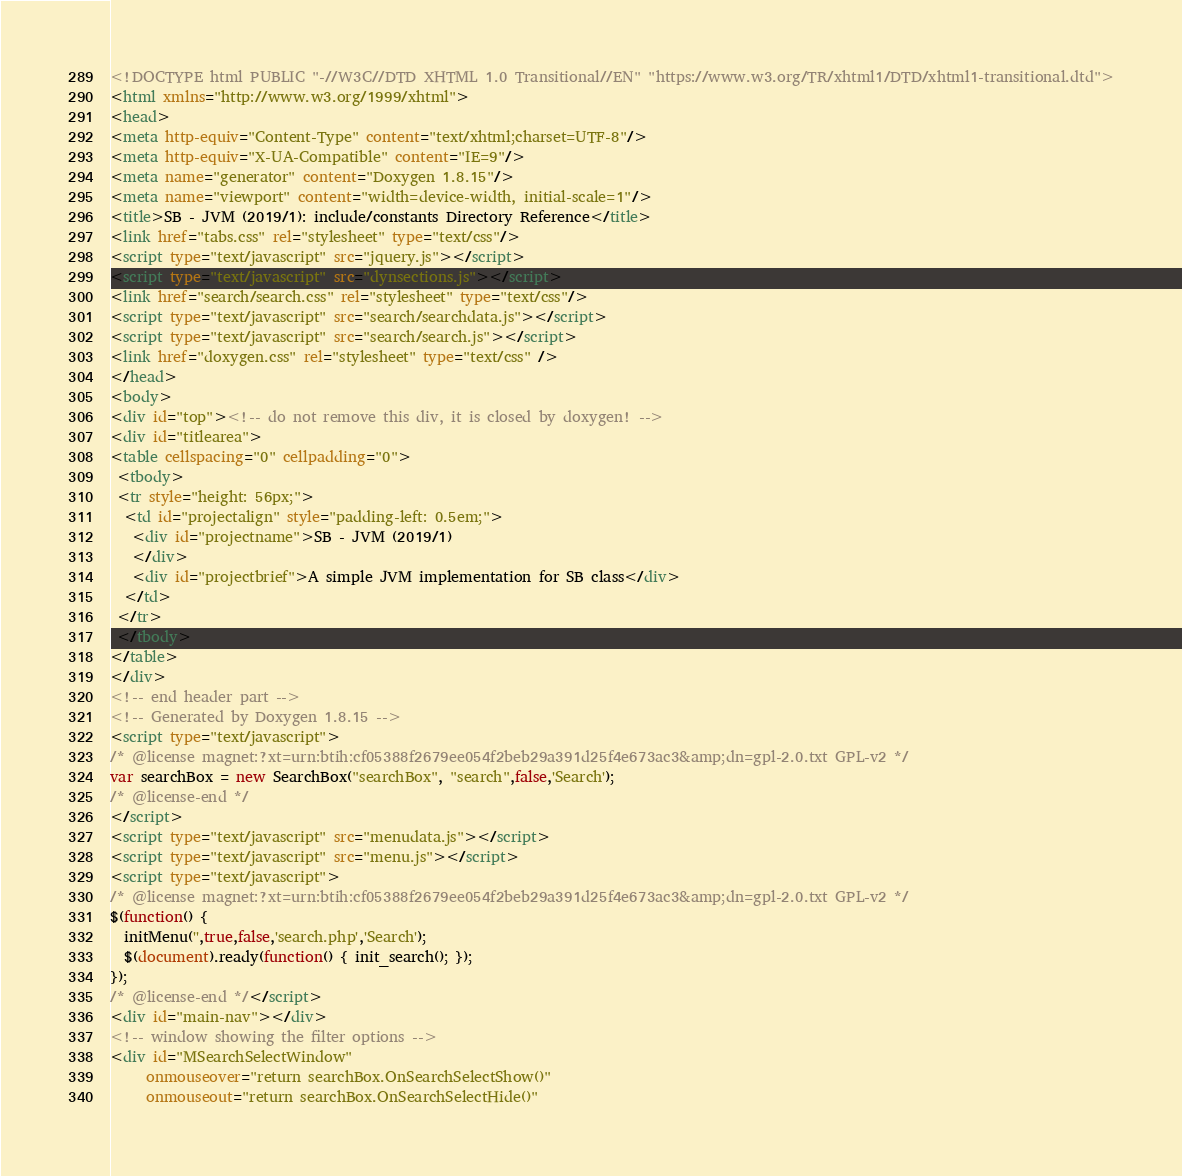Convert code to text. <code><loc_0><loc_0><loc_500><loc_500><_HTML_><!DOCTYPE html PUBLIC "-//W3C//DTD XHTML 1.0 Transitional//EN" "https://www.w3.org/TR/xhtml1/DTD/xhtml1-transitional.dtd">
<html xmlns="http://www.w3.org/1999/xhtml">
<head>
<meta http-equiv="Content-Type" content="text/xhtml;charset=UTF-8"/>
<meta http-equiv="X-UA-Compatible" content="IE=9"/>
<meta name="generator" content="Doxygen 1.8.15"/>
<meta name="viewport" content="width=device-width, initial-scale=1"/>
<title>SB - JVM (2019/1): include/constants Directory Reference</title>
<link href="tabs.css" rel="stylesheet" type="text/css"/>
<script type="text/javascript" src="jquery.js"></script>
<script type="text/javascript" src="dynsections.js"></script>
<link href="search/search.css" rel="stylesheet" type="text/css"/>
<script type="text/javascript" src="search/searchdata.js"></script>
<script type="text/javascript" src="search/search.js"></script>
<link href="doxygen.css" rel="stylesheet" type="text/css" />
</head>
<body>
<div id="top"><!-- do not remove this div, it is closed by doxygen! -->
<div id="titlearea">
<table cellspacing="0" cellpadding="0">
 <tbody>
 <tr style="height: 56px;">
  <td id="projectalign" style="padding-left: 0.5em;">
   <div id="projectname">SB - JVM (2019/1)
   </div>
   <div id="projectbrief">A simple JVM implementation for SB class</div>
  </td>
 </tr>
 </tbody>
</table>
</div>
<!-- end header part -->
<!-- Generated by Doxygen 1.8.15 -->
<script type="text/javascript">
/* @license magnet:?xt=urn:btih:cf05388f2679ee054f2beb29a391d25f4e673ac3&amp;dn=gpl-2.0.txt GPL-v2 */
var searchBox = new SearchBox("searchBox", "search",false,'Search');
/* @license-end */
</script>
<script type="text/javascript" src="menudata.js"></script>
<script type="text/javascript" src="menu.js"></script>
<script type="text/javascript">
/* @license magnet:?xt=urn:btih:cf05388f2679ee054f2beb29a391d25f4e673ac3&amp;dn=gpl-2.0.txt GPL-v2 */
$(function() {
  initMenu('',true,false,'search.php','Search');
  $(document).ready(function() { init_search(); });
});
/* @license-end */</script>
<div id="main-nav"></div>
<!-- window showing the filter options -->
<div id="MSearchSelectWindow"
     onmouseover="return searchBox.OnSearchSelectShow()"
     onmouseout="return searchBox.OnSearchSelectHide()"</code> 